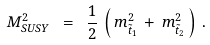<formula> <loc_0><loc_0><loc_500><loc_500>M _ { S U S Y } ^ { 2 } \ = \ \frac { 1 } { 2 } \, \left ( \, m _ { \tilde { t } _ { 1 } } ^ { 2 } \, + \, m _ { \tilde { t } _ { 2 } } ^ { 2 } \, \right ) \, .</formula> 